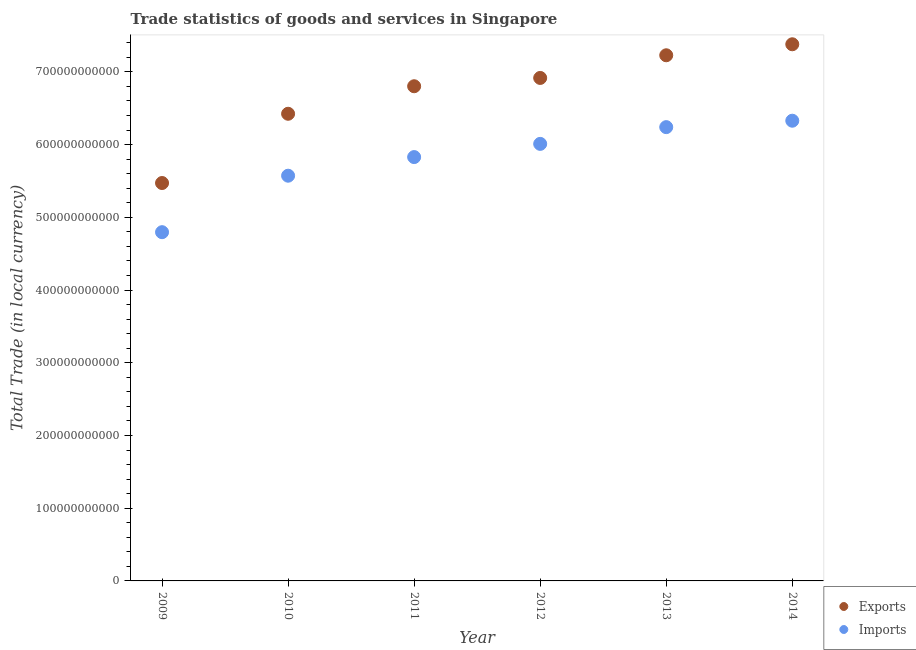How many different coloured dotlines are there?
Offer a terse response. 2. Is the number of dotlines equal to the number of legend labels?
Provide a succinct answer. Yes. What is the export of goods and services in 2010?
Offer a very short reply. 6.42e+11. Across all years, what is the maximum imports of goods and services?
Offer a very short reply. 6.33e+11. Across all years, what is the minimum export of goods and services?
Your answer should be very brief. 5.47e+11. What is the total export of goods and services in the graph?
Your response must be concise. 4.02e+12. What is the difference between the imports of goods and services in 2009 and that in 2011?
Offer a very short reply. -1.03e+11. What is the difference between the export of goods and services in 2014 and the imports of goods and services in 2013?
Offer a terse response. 1.14e+11. What is the average imports of goods and services per year?
Give a very brief answer. 5.80e+11. In the year 2014, what is the difference between the export of goods and services and imports of goods and services?
Keep it short and to the point. 1.05e+11. In how many years, is the imports of goods and services greater than 380000000000 LCU?
Provide a succinct answer. 6. What is the ratio of the imports of goods and services in 2012 to that in 2013?
Your answer should be compact. 0.96. What is the difference between the highest and the second highest imports of goods and services?
Your answer should be compact. 8.82e+09. What is the difference between the highest and the lowest imports of goods and services?
Provide a succinct answer. 1.53e+11. In how many years, is the imports of goods and services greater than the average imports of goods and services taken over all years?
Give a very brief answer. 4. Is the sum of the export of goods and services in 2011 and 2013 greater than the maximum imports of goods and services across all years?
Keep it short and to the point. Yes. Does the export of goods and services monotonically increase over the years?
Make the answer very short. Yes. Is the export of goods and services strictly less than the imports of goods and services over the years?
Make the answer very short. No. How many dotlines are there?
Ensure brevity in your answer.  2. How many years are there in the graph?
Provide a succinct answer. 6. What is the difference between two consecutive major ticks on the Y-axis?
Keep it short and to the point. 1.00e+11. Does the graph contain grids?
Your response must be concise. No. Where does the legend appear in the graph?
Make the answer very short. Bottom right. How many legend labels are there?
Your answer should be very brief. 2. How are the legend labels stacked?
Ensure brevity in your answer.  Vertical. What is the title of the graph?
Your answer should be very brief. Trade statistics of goods and services in Singapore. Does "Excluding technical cooperation" appear as one of the legend labels in the graph?
Your answer should be compact. No. What is the label or title of the X-axis?
Your answer should be very brief. Year. What is the label or title of the Y-axis?
Provide a succinct answer. Total Trade (in local currency). What is the Total Trade (in local currency) of Exports in 2009?
Keep it short and to the point. 5.47e+11. What is the Total Trade (in local currency) in Imports in 2009?
Your response must be concise. 4.80e+11. What is the Total Trade (in local currency) of Exports in 2010?
Ensure brevity in your answer.  6.42e+11. What is the Total Trade (in local currency) in Imports in 2010?
Ensure brevity in your answer.  5.57e+11. What is the Total Trade (in local currency) in Exports in 2011?
Offer a very short reply. 6.80e+11. What is the Total Trade (in local currency) in Imports in 2011?
Make the answer very short. 5.83e+11. What is the Total Trade (in local currency) in Exports in 2012?
Provide a short and direct response. 6.92e+11. What is the Total Trade (in local currency) of Imports in 2012?
Your response must be concise. 6.01e+11. What is the Total Trade (in local currency) of Exports in 2013?
Offer a terse response. 7.23e+11. What is the Total Trade (in local currency) in Imports in 2013?
Keep it short and to the point. 6.24e+11. What is the Total Trade (in local currency) of Exports in 2014?
Provide a succinct answer. 7.38e+11. What is the Total Trade (in local currency) in Imports in 2014?
Your answer should be compact. 6.33e+11. Across all years, what is the maximum Total Trade (in local currency) in Exports?
Your answer should be very brief. 7.38e+11. Across all years, what is the maximum Total Trade (in local currency) in Imports?
Give a very brief answer. 6.33e+11. Across all years, what is the minimum Total Trade (in local currency) of Exports?
Your answer should be very brief. 5.47e+11. Across all years, what is the minimum Total Trade (in local currency) of Imports?
Give a very brief answer. 4.80e+11. What is the total Total Trade (in local currency) of Exports in the graph?
Provide a short and direct response. 4.02e+12. What is the total Total Trade (in local currency) of Imports in the graph?
Ensure brevity in your answer.  3.48e+12. What is the difference between the Total Trade (in local currency) in Exports in 2009 and that in 2010?
Your answer should be very brief. -9.52e+1. What is the difference between the Total Trade (in local currency) in Imports in 2009 and that in 2010?
Offer a terse response. -7.77e+1. What is the difference between the Total Trade (in local currency) of Exports in 2009 and that in 2011?
Your answer should be very brief. -1.33e+11. What is the difference between the Total Trade (in local currency) of Imports in 2009 and that in 2011?
Ensure brevity in your answer.  -1.03e+11. What is the difference between the Total Trade (in local currency) in Exports in 2009 and that in 2012?
Your answer should be very brief. -1.44e+11. What is the difference between the Total Trade (in local currency) of Imports in 2009 and that in 2012?
Offer a terse response. -1.21e+11. What is the difference between the Total Trade (in local currency) of Exports in 2009 and that in 2013?
Provide a succinct answer. -1.76e+11. What is the difference between the Total Trade (in local currency) of Imports in 2009 and that in 2013?
Give a very brief answer. -1.44e+11. What is the difference between the Total Trade (in local currency) in Exports in 2009 and that in 2014?
Make the answer very short. -1.91e+11. What is the difference between the Total Trade (in local currency) of Imports in 2009 and that in 2014?
Offer a very short reply. -1.53e+11. What is the difference between the Total Trade (in local currency) in Exports in 2010 and that in 2011?
Make the answer very short. -3.79e+1. What is the difference between the Total Trade (in local currency) in Imports in 2010 and that in 2011?
Make the answer very short. -2.56e+1. What is the difference between the Total Trade (in local currency) in Exports in 2010 and that in 2012?
Provide a short and direct response. -4.93e+1. What is the difference between the Total Trade (in local currency) in Imports in 2010 and that in 2012?
Your response must be concise. -4.38e+1. What is the difference between the Total Trade (in local currency) of Exports in 2010 and that in 2013?
Ensure brevity in your answer.  -8.04e+1. What is the difference between the Total Trade (in local currency) of Imports in 2010 and that in 2013?
Your answer should be compact. -6.68e+1. What is the difference between the Total Trade (in local currency) of Exports in 2010 and that in 2014?
Keep it short and to the point. -9.56e+1. What is the difference between the Total Trade (in local currency) in Imports in 2010 and that in 2014?
Your response must be concise. -7.56e+1. What is the difference between the Total Trade (in local currency) in Exports in 2011 and that in 2012?
Your response must be concise. -1.14e+1. What is the difference between the Total Trade (in local currency) in Imports in 2011 and that in 2012?
Make the answer very short. -1.82e+1. What is the difference between the Total Trade (in local currency) of Exports in 2011 and that in 2013?
Offer a terse response. -4.26e+1. What is the difference between the Total Trade (in local currency) of Imports in 2011 and that in 2013?
Your answer should be compact. -4.12e+1. What is the difference between the Total Trade (in local currency) of Exports in 2011 and that in 2014?
Provide a succinct answer. -5.77e+1. What is the difference between the Total Trade (in local currency) of Imports in 2011 and that in 2014?
Your answer should be compact. -5.00e+1. What is the difference between the Total Trade (in local currency) of Exports in 2012 and that in 2013?
Give a very brief answer. -3.12e+1. What is the difference between the Total Trade (in local currency) in Imports in 2012 and that in 2013?
Provide a short and direct response. -2.30e+1. What is the difference between the Total Trade (in local currency) of Exports in 2012 and that in 2014?
Offer a terse response. -4.63e+1. What is the difference between the Total Trade (in local currency) in Imports in 2012 and that in 2014?
Make the answer very short. -3.18e+1. What is the difference between the Total Trade (in local currency) of Exports in 2013 and that in 2014?
Provide a short and direct response. -1.51e+1. What is the difference between the Total Trade (in local currency) of Imports in 2013 and that in 2014?
Provide a succinct answer. -8.82e+09. What is the difference between the Total Trade (in local currency) of Exports in 2009 and the Total Trade (in local currency) of Imports in 2010?
Ensure brevity in your answer.  -1.01e+1. What is the difference between the Total Trade (in local currency) in Exports in 2009 and the Total Trade (in local currency) in Imports in 2011?
Offer a very short reply. -3.57e+1. What is the difference between the Total Trade (in local currency) of Exports in 2009 and the Total Trade (in local currency) of Imports in 2012?
Your response must be concise. -5.38e+1. What is the difference between the Total Trade (in local currency) of Exports in 2009 and the Total Trade (in local currency) of Imports in 2013?
Ensure brevity in your answer.  -7.68e+1. What is the difference between the Total Trade (in local currency) of Exports in 2009 and the Total Trade (in local currency) of Imports in 2014?
Your answer should be compact. -8.57e+1. What is the difference between the Total Trade (in local currency) in Exports in 2010 and the Total Trade (in local currency) in Imports in 2011?
Offer a terse response. 5.96e+1. What is the difference between the Total Trade (in local currency) in Exports in 2010 and the Total Trade (in local currency) in Imports in 2012?
Make the answer very short. 4.14e+1. What is the difference between the Total Trade (in local currency) in Exports in 2010 and the Total Trade (in local currency) in Imports in 2013?
Make the answer very short. 1.84e+1. What is the difference between the Total Trade (in local currency) of Exports in 2010 and the Total Trade (in local currency) of Imports in 2014?
Offer a terse response. 9.56e+09. What is the difference between the Total Trade (in local currency) in Exports in 2011 and the Total Trade (in local currency) in Imports in 2012?
Offer a terse response. 7.92e+1. What is the difference between the Total Trade (in local currency) of Exports in 2011 and the Total Trade (in local currency) of Imports in 2013?
Your response must be concise. 5.62e+1. What is the difference between the Total Trade (in local currency) in Exports in 2011 and the Total Trade (in local currency) in Imports in 2014?
Provide a short and direct response. 4.74e+1. What is the difference between the Total Trade (in local currency) of Exports in 2012 and the Total Trade (in local currency) of Imports in 2013?
Keep it short and to the point. 6.76e+1. What is the difference between the Total Trade (in local currency) of Exports in 2012 and the Total Trade (in local currency) of Imports in 2014?
Provide a short and direct response. 5.88e+1. What is the difference between the Total Trade (in local currency) of Exports in 2013 and the Total Trade (in local currency) of Imports in 2014?
Give a very brief answer. 9.00e+1. What is the average Total Trade (in local currency) of Exports per year?
Ensure brevity in your answer.  6.70e+11. What is the average Total Trade (in local currency) in Imports per year?
Ensure brevity in your answer.  5.80e+11. In the year 2009, what is the difference between the Total Trade (in local currency) in Exports and Total Trade (in local currency) in Imports?
Your response must be concise. 6.76e+1. In the year 2010, what is the difference between the Total Trade (in local currency) of Exports and Total Trade (in local currency) of Imports?
Make the answer very short. 8.52e+1. In the year 2011, what is the difference between the Total Trade (in local currency) of Exports and Total Trade (in local currency) of Imports?
Keep it short and to the point. 9.74e+1. In the year 2012, what is the difference between the Total Trade (in local currency) of Exports and Total Trade (in local currency) of Imports?
Provide a succinct answer. 9.07e+1. In the year 2013, what is the difference between the Total Trade (in local currency) of Exports and Total Trade (in local currency) of Imports?
Your answer should be very brief. 9.88e+1. In the year 2014, what is the difference between the Total Trade (in local currency) of Exports and Total Trade (in local currency) of Imports?
Your answer should be compact. 1.05e+11. What is the ratio of the Total Trade (in local currency) of Exports in 2009 to that in 2010?
Make the answer very short. 0.85. What is the ratio of the Total Trade (in local currency) in Imports in 2009 to that in 2010?
Keep it short and to the point. 0.86. What is the ratio of the Total Trade (in local currency) of Exports in 2009 to that in 2011?
Provide a short and direct response. 0.8. What is the ratio of the Total Trade (in local currency) in Imports in 2009 to that in 2011?
Keep it short and to the point. 0.82. What is the ratio of the Total Trade (in local currency) of Exports in 2009 to that in 2012?
Your answer should be very brief. 0.79. What is the ratio of the Total Trade (in local currency) of Imports in 2009 to that in 2012?
Ensure brevity in your answer.  0.8. What is the ratio of the Total Trade (in local currency) of Exports in 2009 to that in 2013?
Your answer should be compact. 0.76. What is the ratio of the Total Trade (in local currency) in Imports in 2009 to that in 2013?
Give a very brief answer. 0.77. What is the ratio of the Total Trade (in local currency) in Exports in 2009 to that in 2014?
Your answer should be very brief. 0.74. What is the ratio of the Total Trade (in local currency) of Imports in 2009 to that in 2014?
Keep it short and to the point. 0.76. What is the ratio of the Total Trade (in local currency) in Exports in 2010 to that in 2011?
Ensure brevity in your answer.  0.94. What is the ratio of the Total Trade (in local currency) in Imports in 2010 to that in 2011?
Provide a succinct answer. 0.96. What is the ratio of the Total Trade (in local currency) in Exports in 2010 to that in 2012?
Offer a very short reply. 0.93. What is the ratio of the Total Trade (in local currency) in Imports in 2010 to that in 2012?
Give a very brief answer. 0.93. What is the ratio of the Total Trade (in local currency) of Exports in 2010 to that in 2013?
Your response must be concise. 0.89. What is the ratio of the Total Trade (in local currency) in Imports in 2010 to that in 2013?
Provide a short and direct response. 0.89. What is the ratio of the Total Trade (in local currency) in Exports in 2010 to that in 2014?
Provide a short and direct response. 0.87. What is the ratio of the Total Trade (in local currency) in Imports in 2010 to that in 2014?
Provide a short and direct response. 0.88. What is the ratio of the Total Trade (in local currency) in Exports in 2011 to that in 2012?
Offer a very short reply. 0.98. What is the ratio of the Total Trade (in local currency) of Imports in 2011 to that in 2012?
Your answer should be compact. 0.97. What is the ratio of the Total Trade (in local currency) in Exports in 2011 to that in 2013?
Your response must be concise. 0.94. What is the ratio of the Total Trade (in local currency) of Imports in 2011 to that in 2013?
Keep it short and to the point. 0.93. What is the ratio of the Total Trade (in local currency) of Exports in 2011 to that in 2014?
Offer a very short reply. 0.92. What is the ratio of the Total Trade (in local currency) of Imports in 2011 to that in 2014?
Your response must be concise. 0.92. What is the ratio of the Total Trade (in local currency) in Exports in 2012 to that in 2013?
Offer a very short reply. 0.96. What is the ratio of the Total Trade (in local currency) in Imports in 2012 to that in 2013?
Your answer should be very brief. 0.96. What is the ratio of the Total Trade (in local currency) in Exports in 2012 to that in 2014?
Ensure brevity in your answer.  0.94. What is the ratio of the Total Trade (in local currency) of Imports in 2012 to that in 2014?
Keep it short and to the point. 0.95. What is the ratio of the Total Trade (in local currency) of Exports in 2013 to that in 2014?
Offer a very short reply. 0.98. What is the ratio of the Total Trade (in local currency) of Imports in 2013 to that in 2014?
Make the answer very short. 0.99. What is the difference between the highest and the second highest Total Trade (in local currency) in Exports?
Give a very brief answer. 1.51e+1. What is the difference between the highest and the second highest Total Trade (in local currency) in Imports?
Offer a very short reply. 8.82e+09. What is the difference between the highest and the lowest Total Trade (in local currency) of Exports?
Provide a short and direct response. 1.91e+11. What is the difference between the highest and the lowest Total Trade (in local currency) of Imports?
Make the answer very short. 1.53e+11. 